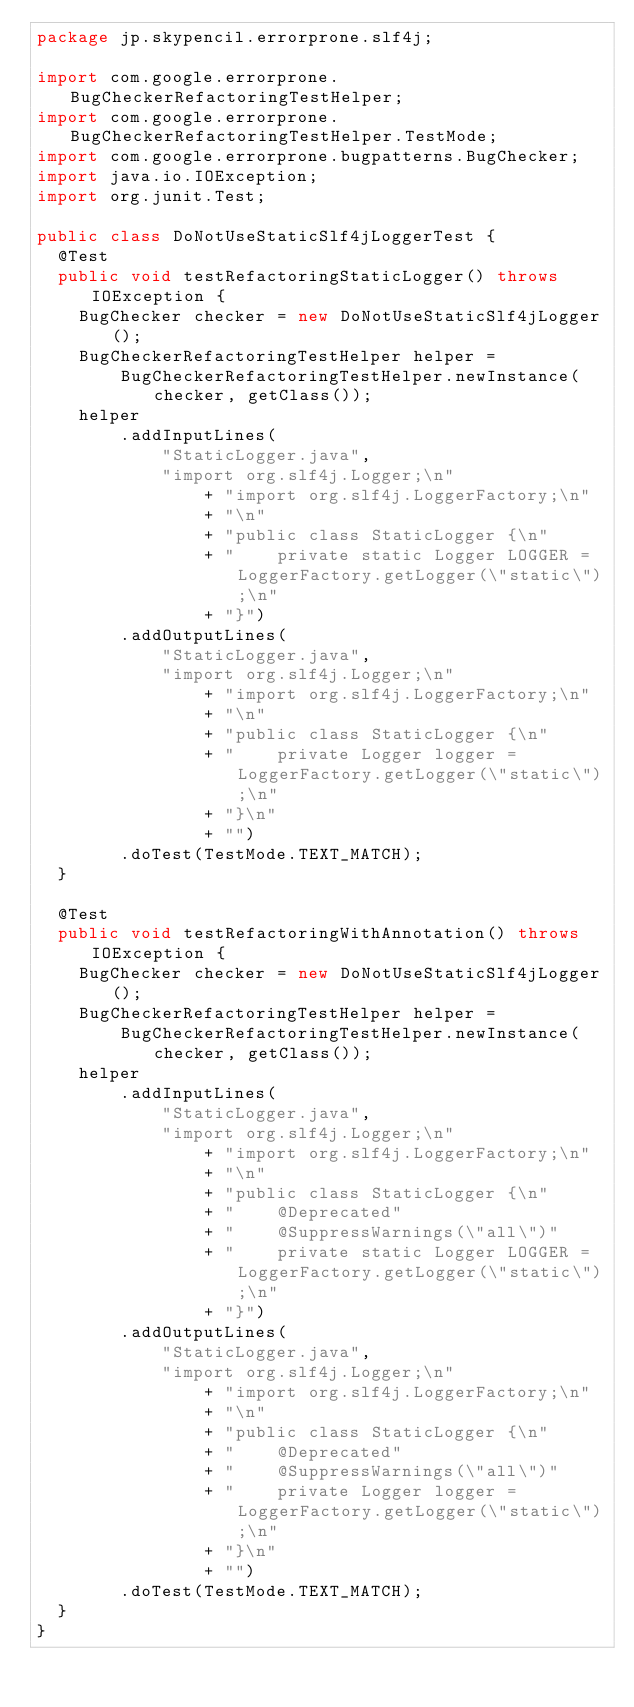<code> <loc_0><loc_0><loc_500><loc_500><_Java_>package jp.skypencil.errorprone.slf4j;

import com.google.errorprone.BugCheckerRefactoringTestHelper;
import com.google.errorprone.BugCheckerRefactoringTestHelper.TestMode;
import com.google.errorprone.bugpatterns.BugChecker;
import java.io.IOException;
import org.junit.Test;

public class DoNotUseStaticSlf4jLoggerTest {
  @Test
  public void testRefactoringStaticLogger() throws IOException {
    BugChecker checker = new DoNotUseStaticSlf4jLogger();
    BugCheckerRefactoringTestHelper helper =
        BugCheckerRefactoringTestHelper.newInstance(checker, getClass());
    helper
        .addInputLines(
            "StaticLogger.java",
            "import org.slf4j.Logger;\n"
                + "import org.slf4j.LoggerFactory;\n"
                + "\n"
                + "public class StaticLogger {\n"
                + "    private static Logger LOGGER = LoggerFactory.getLogger(\"static\");\n"
                + "}")
        .addOutputLines(
            "StaticLogger.java",
            "import org.slf4j.Logger;\n"
                + "import org.slf4j.LoggerFactory;\n"
                + "\n"
                + "public class StaticLogger {\n"
                + "    private Logger logger = LoggerFactory.getLogger(\"static\");\n"
                + "}\n"
                + "")
        .doTest(TestMode.TEXT_MATCH);
  }

  @Test
  public void testRefactoringWithAnnotation() throws IOException {
    BugChecker checker = new DoNotUseStaticSlf4jLogger();
    BugCheckerRefactoringTestHelper helper =
        BugCheckerRefactoringTestHelper.newInstance(checker, getClass());
    helper
        .addInputLines(
            "StaticLogger.java",
            "import org.slf4j.Logger;\n"
                + "import org.slf4j.LoggerFactory;\n"
                + "\n"
                + "public class StaticLogger {\n"
                + "    @Deprecated"
                + "    @SuppressWarnings(\"all\")"
                + "    private static Logger LOGGER = LoggerFactory.getLogger(\"static\");\n"
                + "}")
        .addOutputLines(
            "StaticLogger.java",
            "import org.slf4j.Logger;\n"
                + "import org.slf4j.LoggerFactory;\n"
                + "\n"
                + "public class StaticLogger {\n"
                + "    @Deprecated"
                + "    @SuppressWarnings(\"all\")"
                + "    private Logger logger = LoggerFactory.getLogger(\"static\");\n"
                + "}\n"
                + "")
        .doTest(TestMode.TEXT_MATCH);
  }
}
</code> 